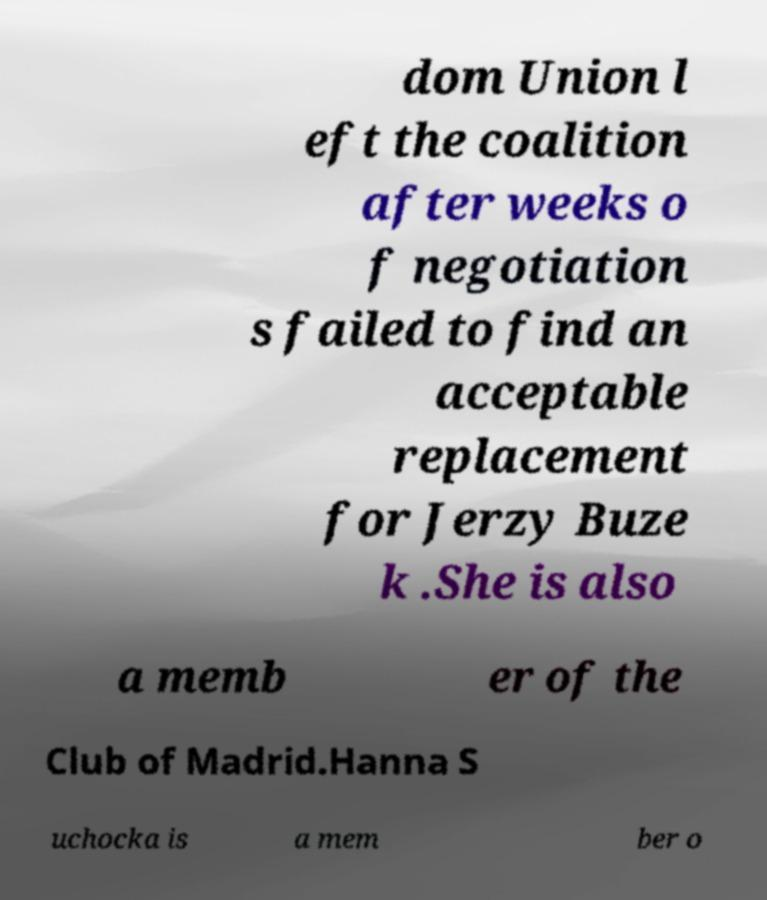I need the written content from this picture converted into text. Can you do that? dom Union l eft the coalition after weeks o f negotiation s failed to find an acceptable replacement for Jerzy Buze k .She is also a memb er of the Club of Madrid.Hanna S uchocka is a mem ber o 